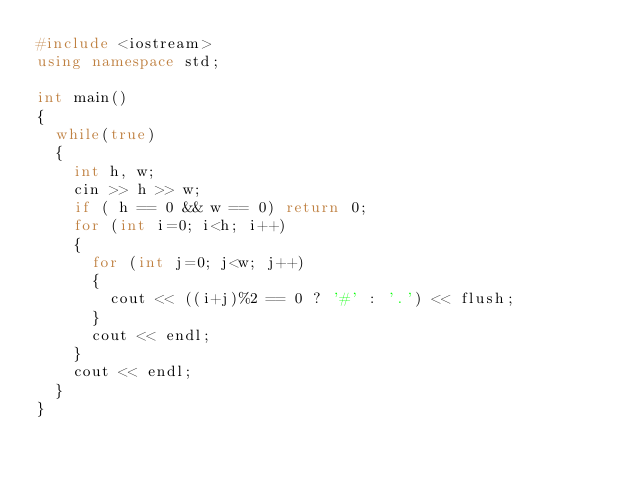<code> <loc_0><loc_0><loc_500><loc_500><_C++_>#include <iostream>
using namespace std;

int main()
{
  while(true)
  {
    int h, w;
    cin >> h >> w;
    if ( h == 0 && w == 0) return 0;
    for (int i=0; i<h; i++)
    {
      for (int j=0; j<w; j++)
      {
        cout << ((i+j)%2 == 0 ? '#' : '.') << flush;
      }
      cout << endl;
    }
    cout << endl;
  }
}</code> 